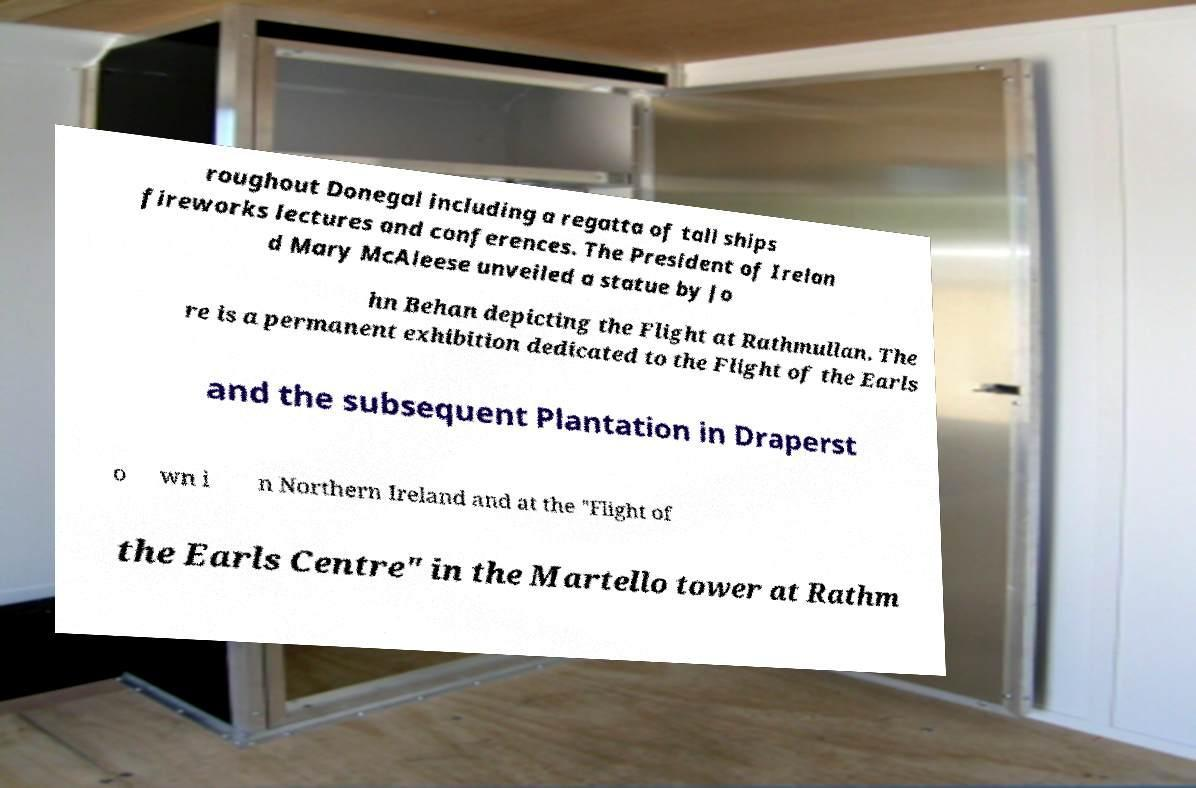For documentation purposes, I need the text within this image transcribed. Could you provide that? roughout Donegal including a regatta of tall ships fireworks lectures and conferences. The President of Irelan d Mary McAleese unveiled a statue by Jo hn Behan depicting the Flight at Rathmullan. The re is a permanent exhibition dedicated to the Flight of the Earls and the subsequent Plantation in Draperst o wn i n Northern Ireland and at the "Flight of the Earls Centre" in the Martello tower at Rathm 